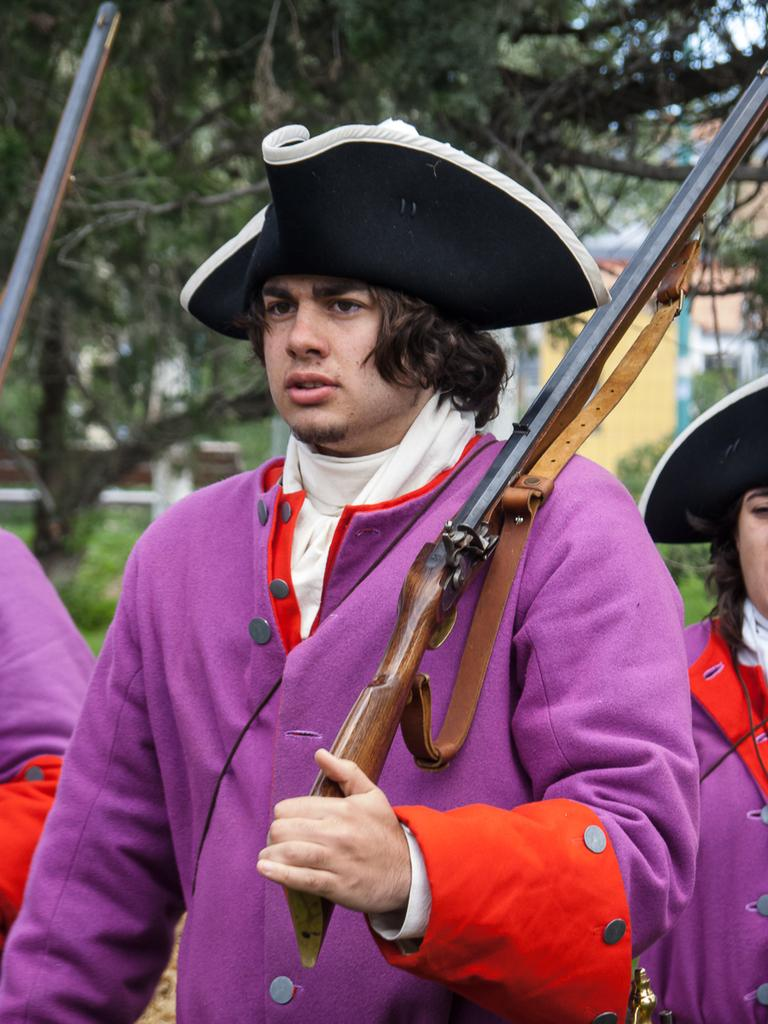What is the person in the image holding? The person in the image is holding a gun. Are there any other people in the image? Yes, there are other persons standing beside the person with the gun. What can be seen in the background of the image? There are trees and a building visible in the background of the image. What type of education is the person with the gun pursuing in the image? There is no indication of education in the image; it only shows a person holding a gun and other people standing nearby. 